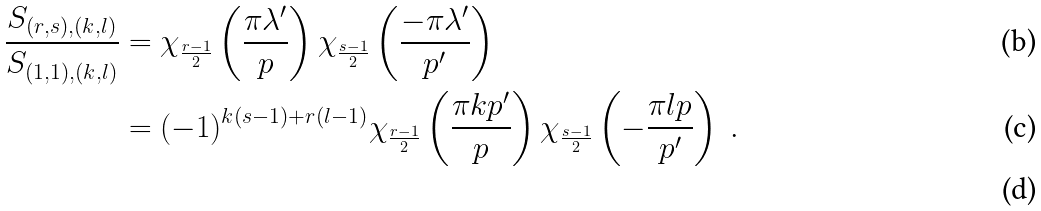Convert formula to latex. <formula><loc_0><loc_0><loc_500><loc_500>\frac { S _ { ( r , s ) , ( k , l ) } } { S _ { ( 1 , 1 ) , ( k , l ) } } & = \chi _ { \frac { r - 1 } { 2 } } \left ( \frac { \pi \lambda ^ { \prime } } { p } \right ) \chi _ { \frac { s - 1 } { 2 } } \left ( \frac { - \pi \lambda ^ { \prime } } { p ^ { \prime } } \right ) \\ & = ( - 1 ) ^ { k ( s - 1 ) + r ( l - 1 ) } \chi _ { \frac { r - 1 } { 2 } } \left ( \frac { \pi k p ^ { \prime } } { p } \right ) \chi _ { \frac { s - 1 } { 2 } } \left ( - \frac { \pi l p } { p ^ { \prime } } \right ) \ . \\</formula> 